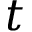<formula> <loc_0><loc_0><loc_500><loc_500>t</formula> 